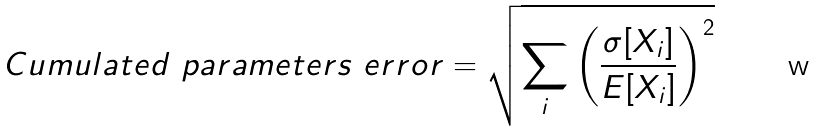Convert formula to latex. <formula><loc_0><loc_0><loc_500><loc_500>C u m u l a t e d \ p a r a m e t e r s \ e r r o r = \sqrt { \sum _ { i } \left ( \frac { \sigma [ X _ { i } ] } { E [ X _ { i } ] } \right ) ^ { 2 } }</formula> 